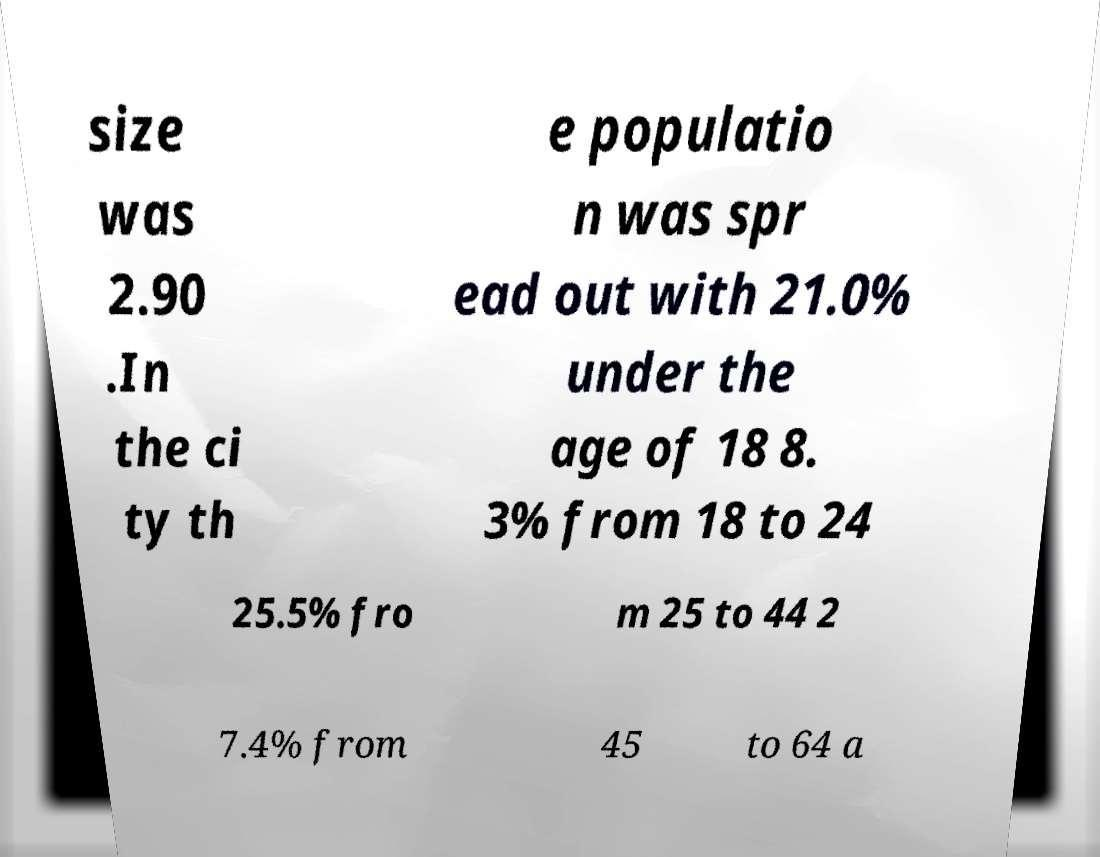Could you assist in decoding the text presented in this image and type it out clearly? size was 2.90 .In the ci ty th e populatio n was spr ead out with 21.0% under the age of 18 8. 3% from 18 to 24 25.5% fro m 25 to 44 2 7.4% from 45 to 64 a 